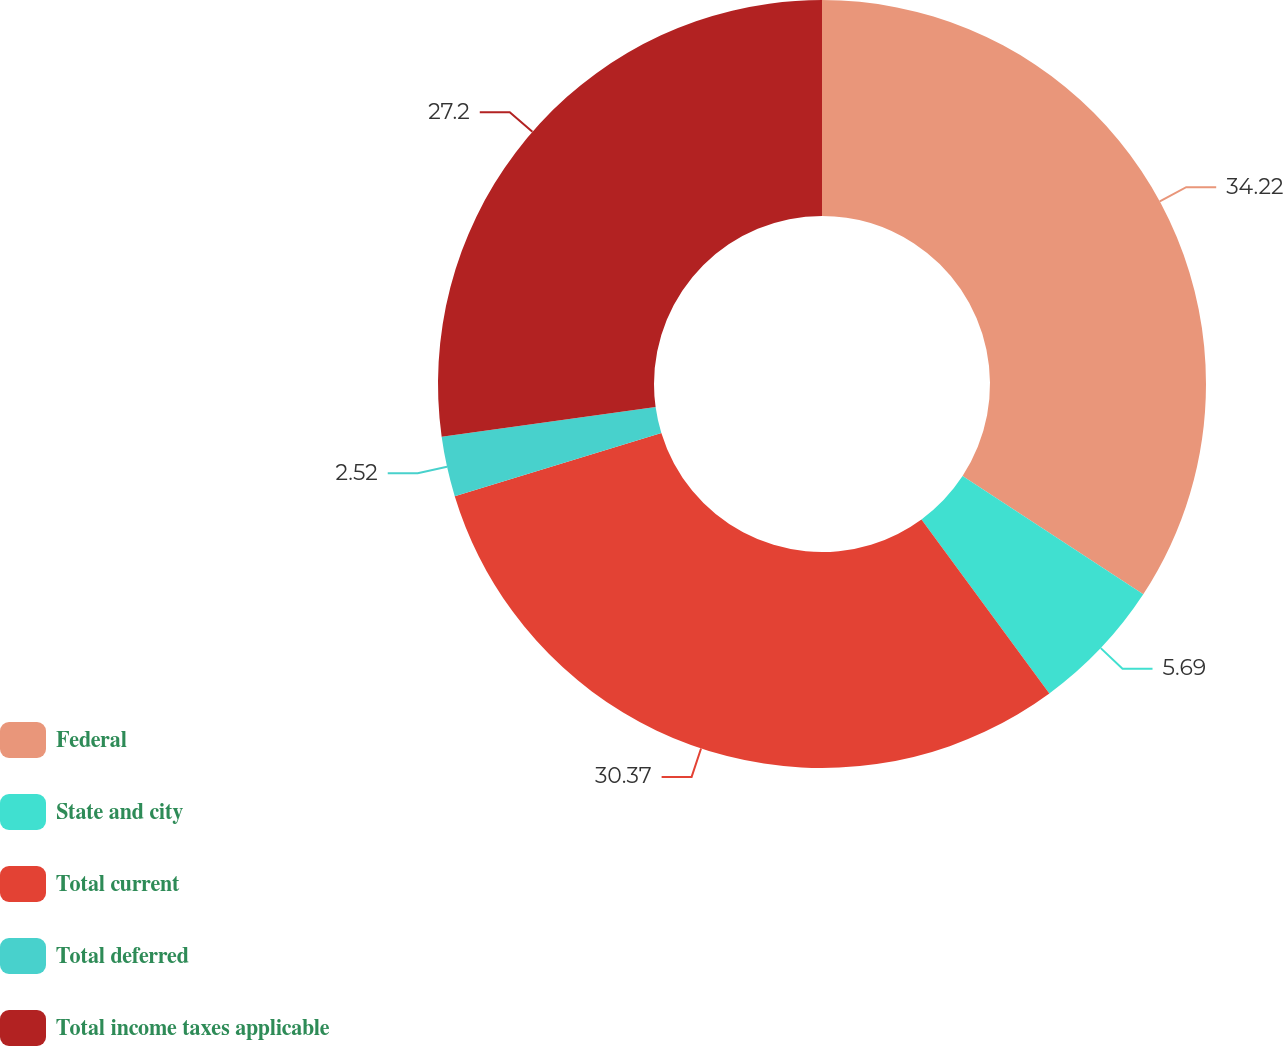Convert chart to OTSL. <chart><loc_0><loc_0><loc_500><loc_500><pie_chart><fcel>Federal<fcel>State and city<fcel>Total current<fcel>Total deferred<fcel>Total income taxes applicable<nl><fcel>34.23%<fcel>5.69%<fcel>30.37%<fcel>2.52%<fcel>27.2%<nl></chart> 